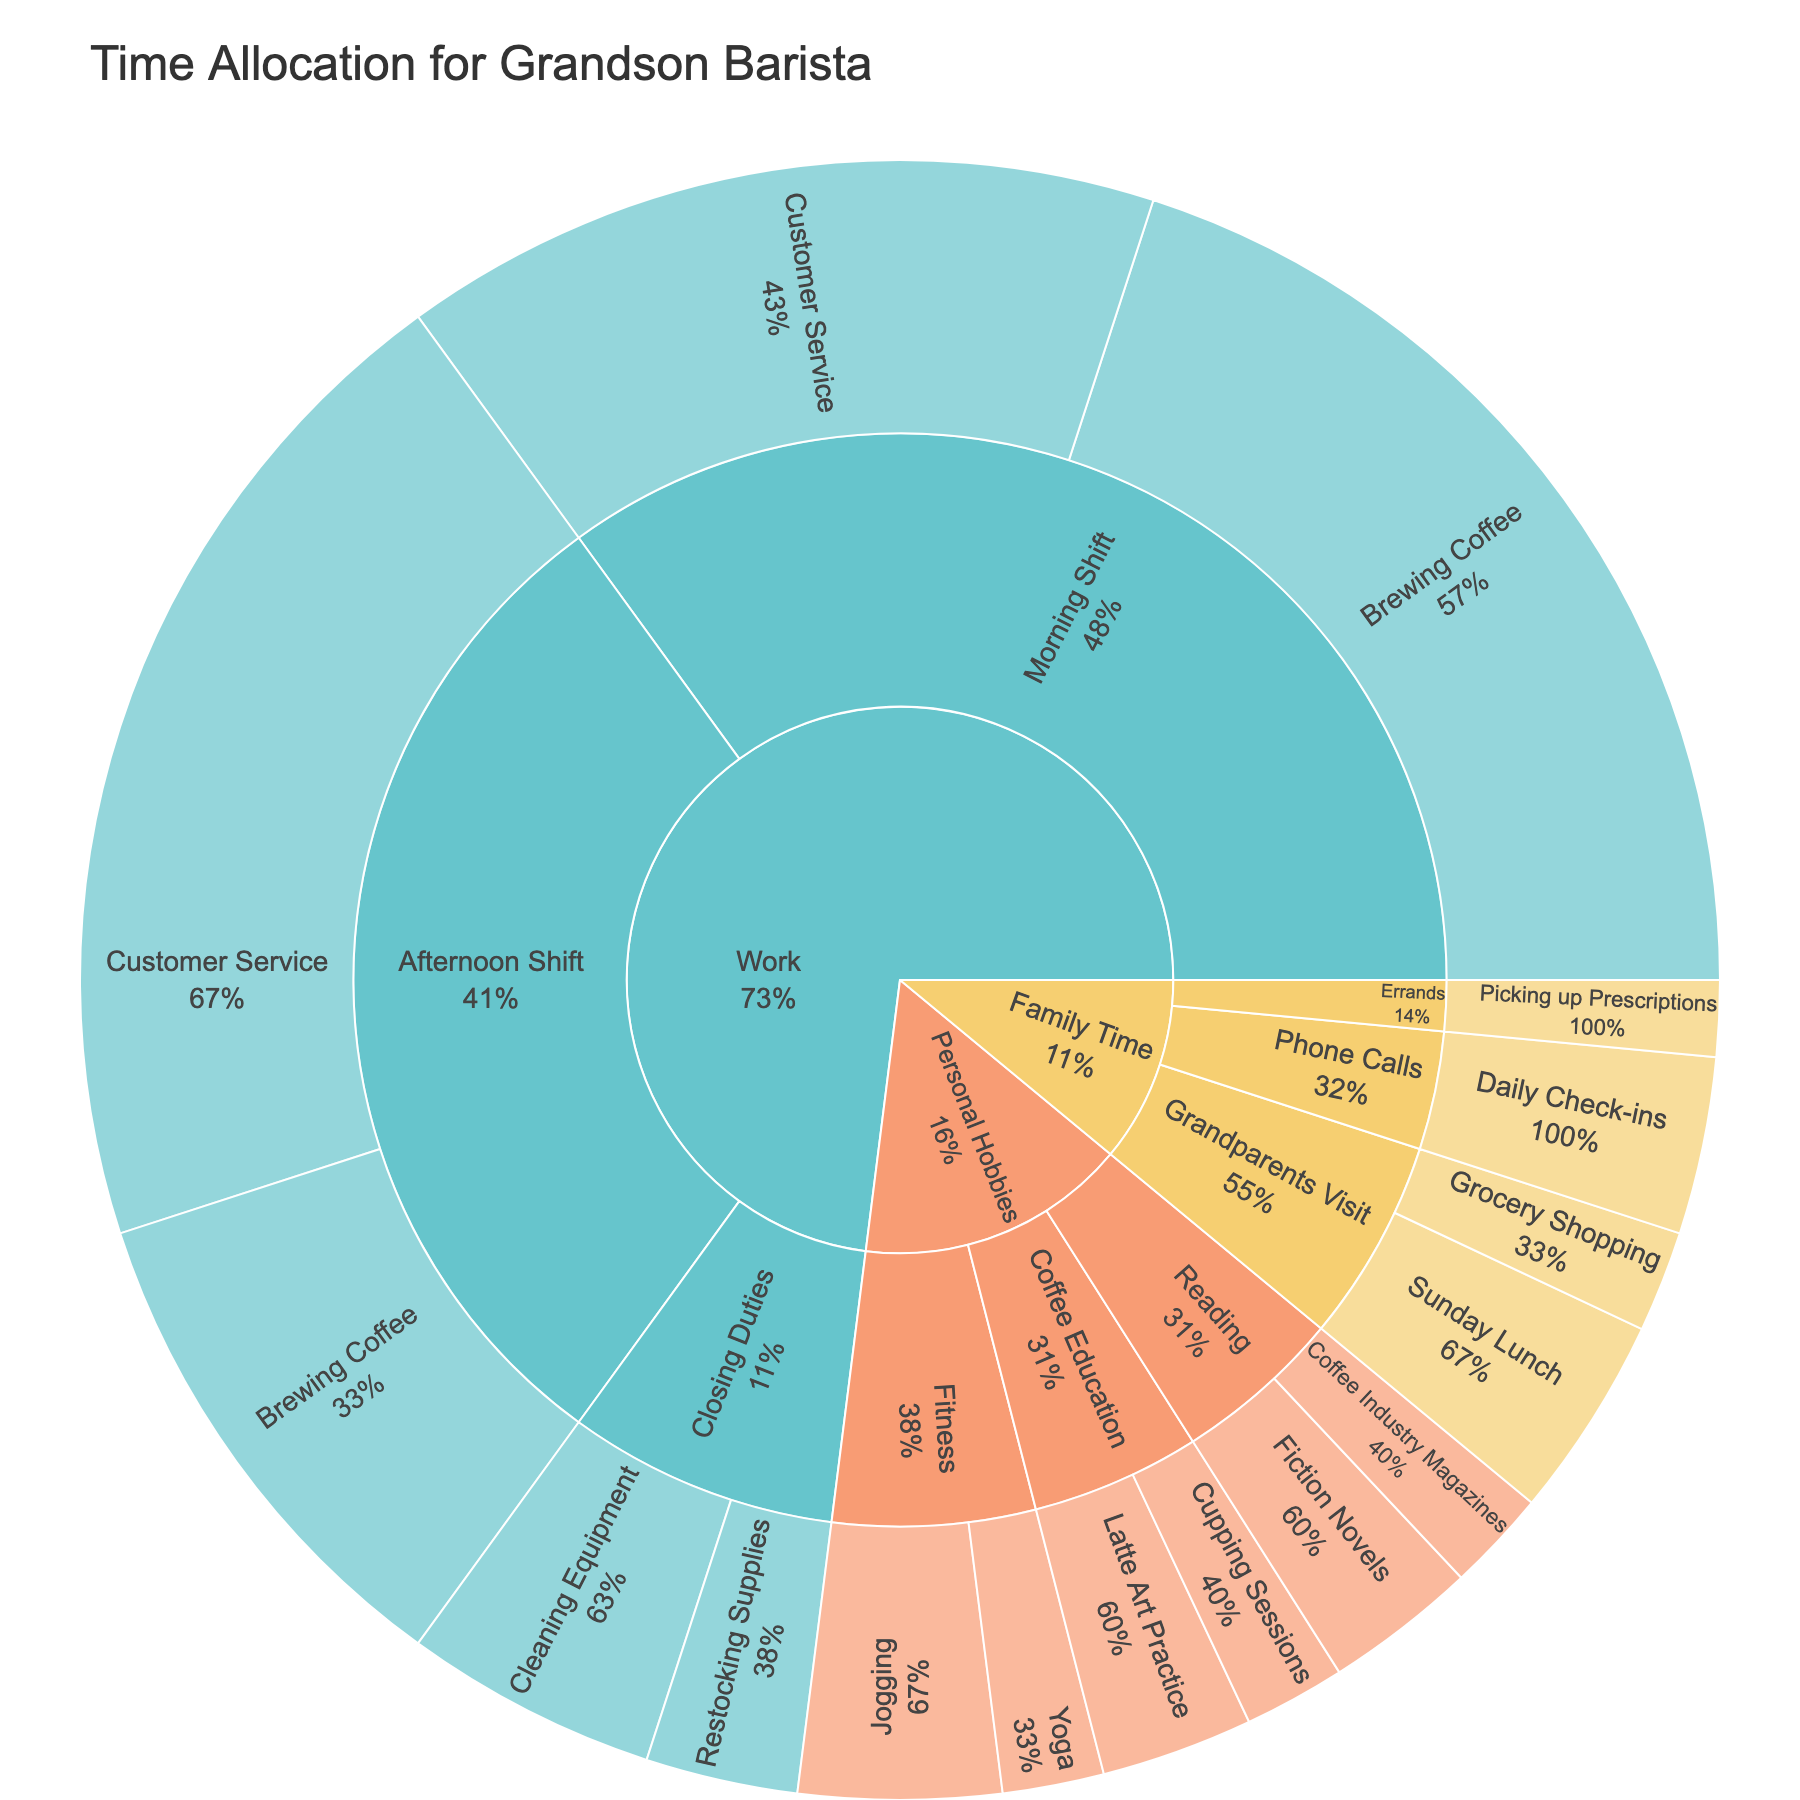What is the title of the sunburst plot? The title of the sunburst plot is placed at the top and provides a concise description of the figure's content.
Answer: Time Allocation for Grandson Barista What percentage of time in the Morning Shift is spent on Brewing Coffee? To find this, locate the Morning Shift segment of Work, then see Brewing Coffee within it to find the percentage. According to the plot, Brewing Coffee in the Morning Shift accounts for 57.14% of the Morning Shift.
Answer: 57.14% How much total time is allocated to Family Time activities? Sum the total hours dedicated to each subcategory under Family Time (Sunday Lunch: 4, Grocery Shopping: 2, Daily Check-ins: 3.5, Picking up Prescriptions: 1.5). Adding these up, 4 + 2 + 3.5 + 1.5 = 11.
Answer: 11 hours Which activity in the Personal Hobbies category has the highest allocation of time? Within Personal Hobbies, observe each activity's allocated time. Jogging has the highest allocation with 4 hours.
Answer: Jogging Compare the hours spent on Customer Service in the Morning Shift and Afternoon Shift. Which one is higher, and by how much? Customer Service in the Morning Shift is 15 hours and in the Afternoon Shift is 20 hours. Subtract the lower value from the higher one: 20 - 15 = 5.
Answer: Afternoon Shift by 5 hours What are the subcategories under the Work category? The first segments branching out from Work node represent the subcategories, which are Morning Shift, Afternoon Shift, and Closing Duties.
Answer: Morning Shift, Afternoon Shift, Closing Duties Calculate the total hours spent on Brewing Coffee across all shifts. Sum the hours spent on Brewing Coffee in both Morning Shift and Afternoon Shift: 20 (Morning) + 10 (Afternoon) = 30.
Answer: 30 hours What is the overall percentage of time allocated to Fitness activities out of Personal Hobbies? Combine the hours within Fitness: Jogging (4) and Yoga (2), totaling 6 hours. The total hours for Personal Hobbies are 3 (Latte Art Practice) + 2 (Cupping Sessions) + 4 (Jogging) + 2 (Yoga) + 2 (Coffee Industry Magazines) + 3 (Fiction Novels) = 16. Now, 6/16 = 0.375 or 37.5%.
Answer: 37.5% Which activity under Family Time has the least hours allocated? Identify the activities under Family Time and compare their hours. Picking up Prescriptions has the least with 1.5 hours.
Answer: Picking up Prescriptions What is the total number of subcategories represented in the plot? Count the distinct subcategories presented under each main category: Morning Shift (2), Afternoon Shift (2), Closing Duties (2), Grandparents Visit (2), Phone Calls (1), Errands (1), Coffee Education (2), Fitness (2), Reading (2). There are 14 in total.
Answer: 14 